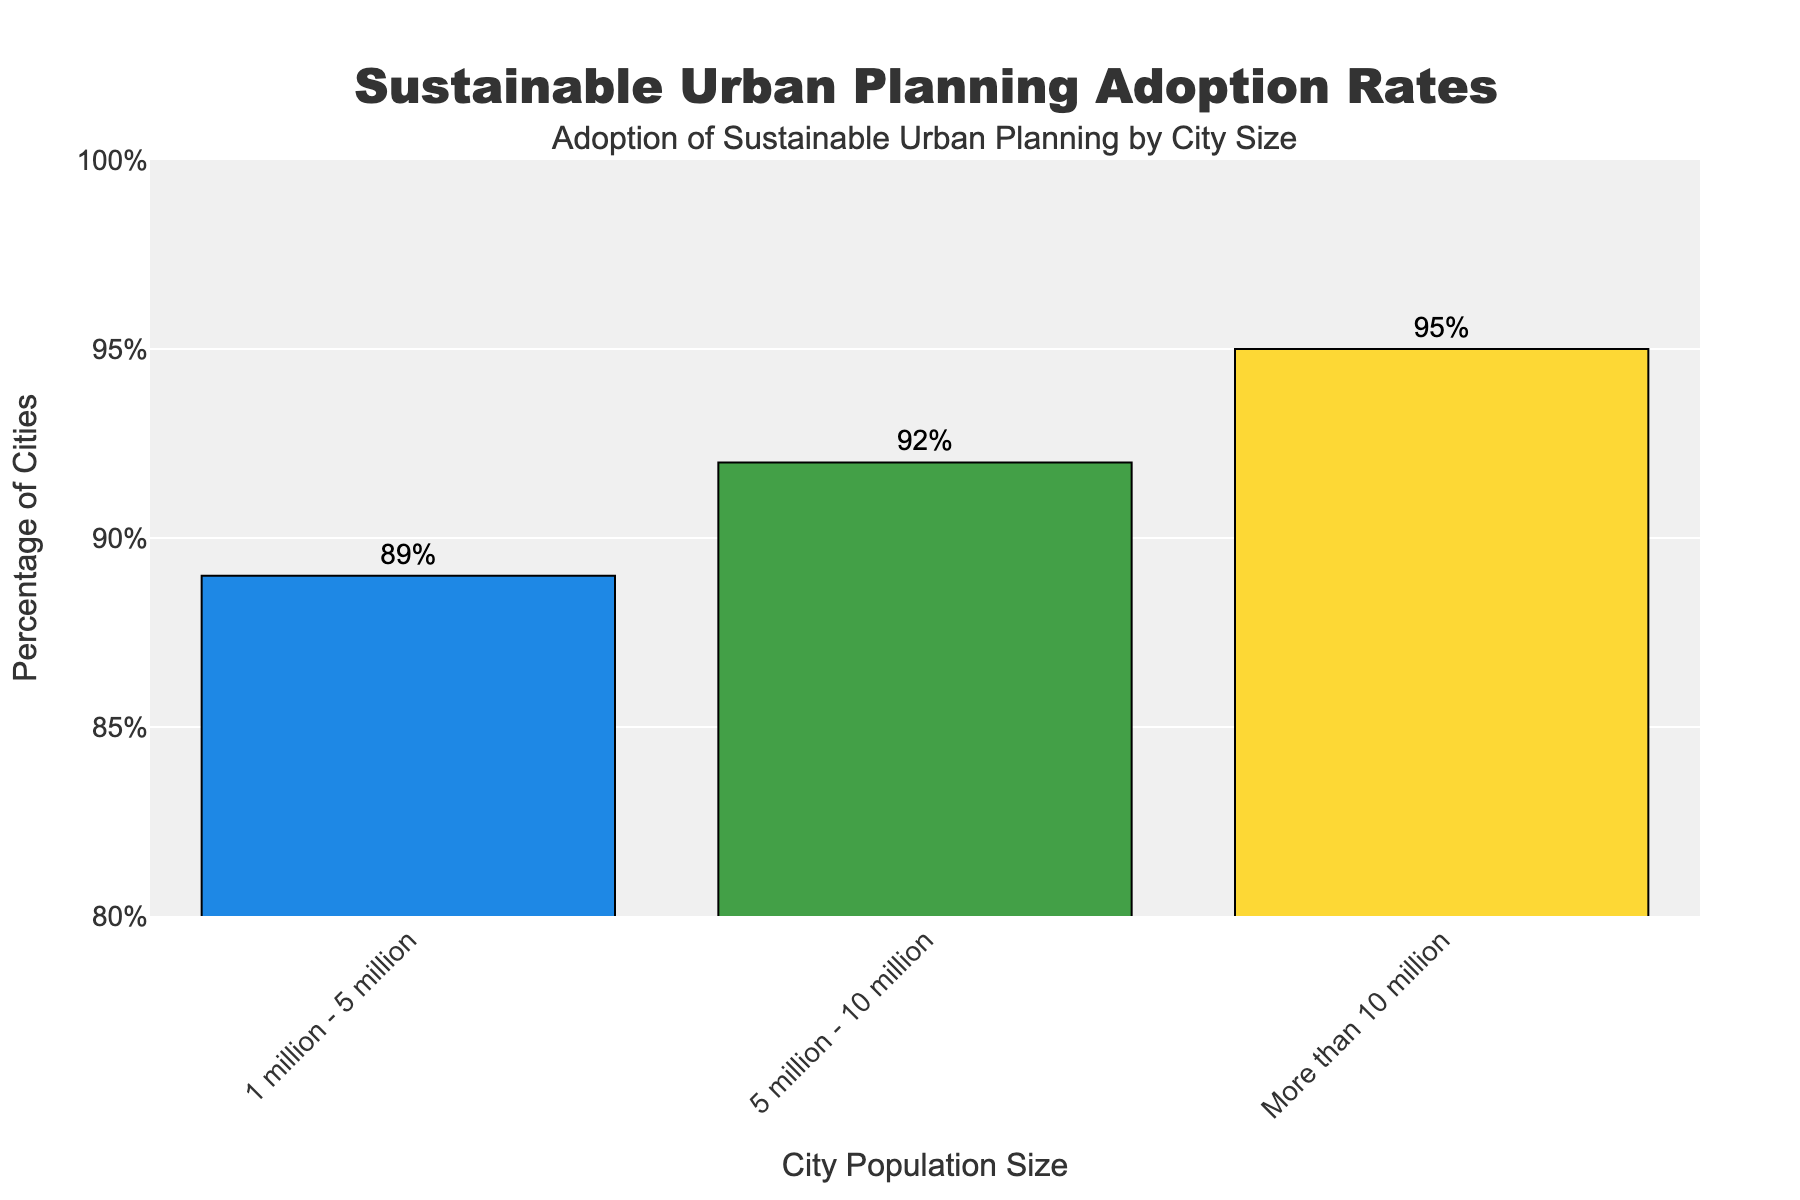What's the percentage of cities with populations between 1 million and 5 million that adopt sustainable urban planning? The percentage of cities with populations between 1 million and 5 million that adopt sustainable urban planning can be directly observed from the bar chart. The bar corresponding to this population size shows a value of 89%.
Answer: 89% Which city population size has the highest adoption rate of sustainable urban planning? By looking at the heights of the bars, the bar for "More than 10 million" is the tallest, indicating it has the highest adoption rate at 95%.
Answer: More than 10 million How much higher is the adoption percentage for cities with populations more than 10 million compared to those with populations between 5 million and 10 million? Subtract the percentage for "5 million - 10 million" (92%) from that for "More than 10 million" (95%). Calculation: 95% - 92% = 3%.
Answer: 3% What is the combined adoption percentage of sustainable urban planning for cities with populations between 1 million to 10 million? Add the percentages for "1 million - 5 million" and "5 million - 10 million". Calculation: 89% (1 million - 5 million) + 92% (5 million - 10 million) = 181%.
Answer: 181% What is the average adoption rate of sustainable urban planning for all city population sizes shown? Add all percentages and then divide by the number of categories. Calculation: (89% + 92% + 95%) / 3 = 276% / 3 = 92%.
Answer: 92% Which color is used to represent the adoption rate for cities with populations between 1 million and 5 million? The bars are color-coded, and the bar for "1 million - 5 million" is shown in a blue color.
Answer: Blue Is the adoption percentage for cities with populations more than 10 million more than 90%? Compare the value for "More than 10 million" with 90%. The adoption percentage for "More than 10 million" is 95%, which is more than 90%.
Answer: Yes Between which two population sizes is there the smallest difference in adoption rates? Calculate the differences between each pair: 5 million - 10 million (92%) and More than 10 million (95%) difference is 3%; 1 million - 5 million (89%) and 5 million - 10 million (92%) difference is 3%. Both differences are equal at 3%.
Answer: 1 million - 5 million and 5 million - 10 million What is the total percentage adoption for all city sizes combined? Add the percentages of all bars. Calculation: 89% + 92% + 95% = 276%.
Answer: 276% Which population size range shows an adoption rate below 90%? Examine the bars and their corresponding percentages to find values below 90%. The bar for "1 million - 5 million" shows an 89% adoption rate, which is below 90%.
Answer: 1 million - 5 million 